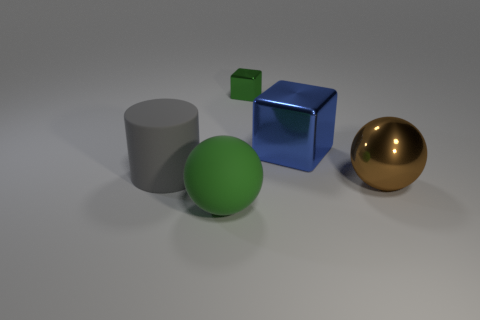Add 4 tiny yellow matte spheres. How many objects exist? 9 Subtract all green balls. How many balls are left? 1 Subtract 1 cylinders. How many cylinders are left? 0 Subtract all blocks. How many objects are left? 3 Subtract 1 blue blocks. How many objects are left? 4 Subtract all gray balls. Subtract all gray blocks. How many balls are left? 2 Subtract all large green spheres. Subtract all blue shiny cubes. How many objects are left? 3 Add 2 matte things. How many matte things are left? 4 Add 3 big blue things. How many big blue things exist? 4 